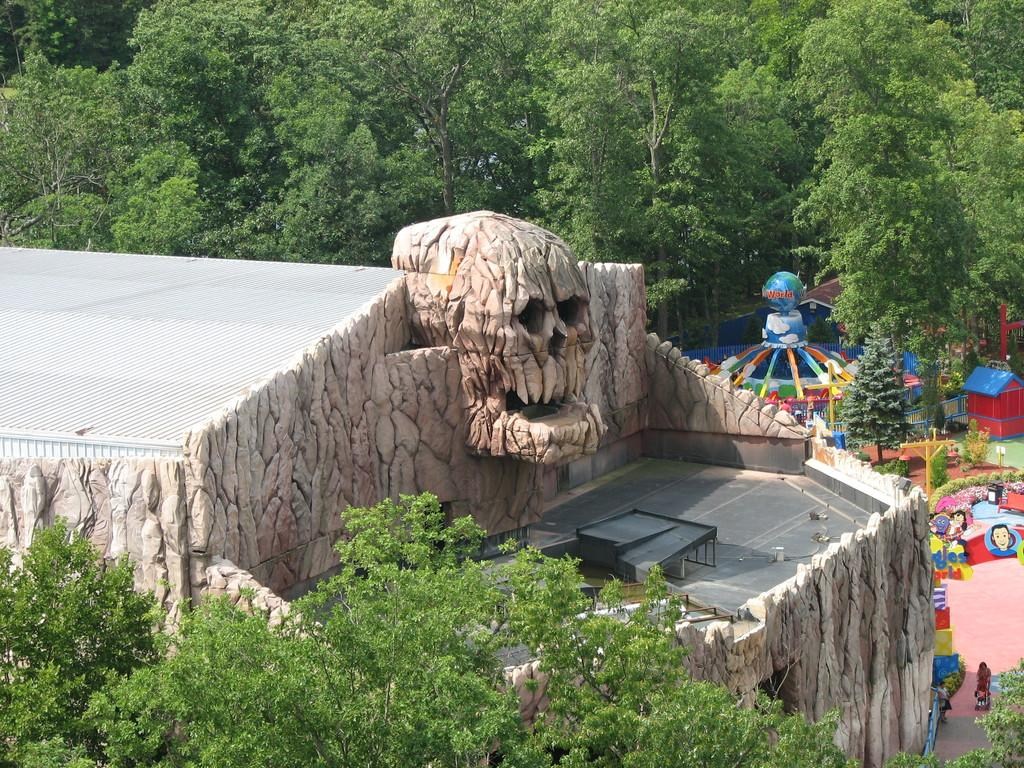What type of vegetation is at the bottom of the image? There are trees at the bottom of the image. What structure is located on the left side of the image? There is a building on the left side of the image. What can be found on the floor in the image? There are objects on the floor in the image. What is visible in the background of the image? There are trees, amusing rides, poles, and other objects in the background of the image. What color is the crayon used to draw the art in the image? There is no art or crayon present in the image. Do you believe the objects in the background are real or just an illusion? The question of whether the objects in the background are real or an illusion cannot be answered definitively from the image alone, as it is a matter of interpretation. 